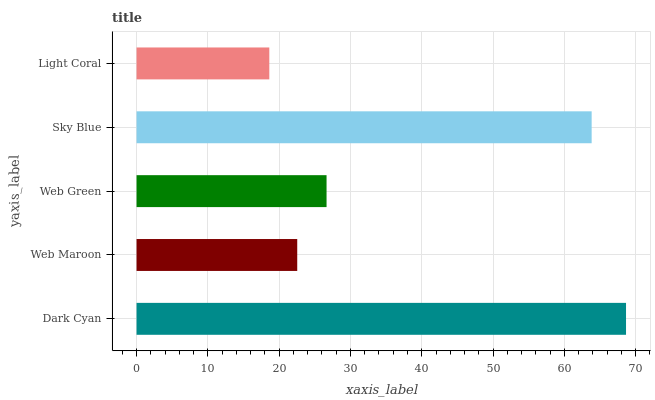Is Light Coral the minimum?
Answer yes or no. Yes. Is Dark Cyan the maximum?
Answer yes or no. Yes. Is Web Maroon the minimum?
Answer yes or no. No. Is Web Maroon the maximum?
Answer yes or no. No. Is Dark Cyan greater than Web Maroon?
Answer yes or no. Yes. Is Web Maroon less than Dark Cyan?
Answer yes or no. Yes. Is Web Maroon greater than Dark Cyan?
Answer yes or no. No. Is Dark Cyan less than Web Maroon?
Answer yes or no. No. Is Web Green the high median?
Answer yes or no. Yes. Is Web Green the low median?
Answer yes or no. Yes. Is Light Coral the high median?
Answer yes or no. No. Is Dark Cyan the low median?
Answer yes or no. No. 